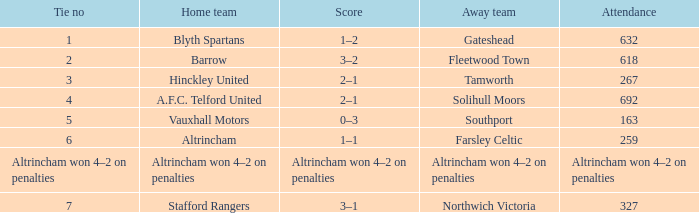Which away side that had a tie with 7 points? Northwich Victoria. 